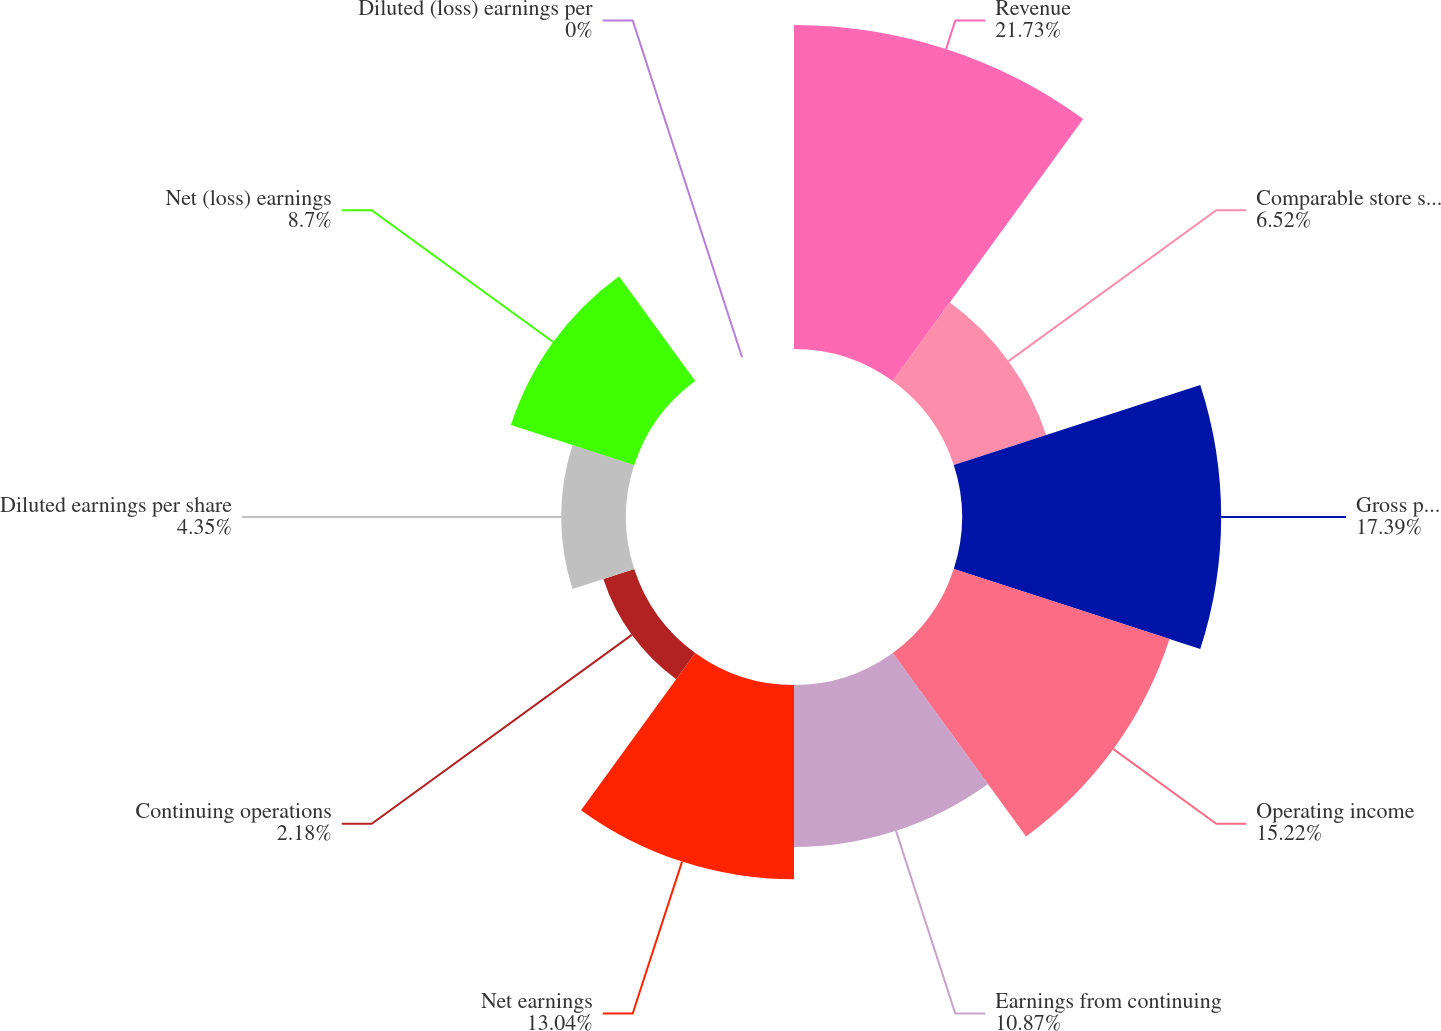Convert chart. <chart><loc_0><loc_0><loc_500><loc_500><pie_chart><fcel>Revenue<fcel>Comparable store sales change<fcel>Gross profit<fcel>Operating income<fcel>Earnings from continuing<fcel>Net earnings<fcel>Continuing operations<fcel>Diluted earnings per share<fcel>Net (loss) earnings<fcel>Diluted (loss) earnings per<nl><fcel>21.74%<fcel>6.52%<fcel>17.39%<fcel>15.22%<fcel>10.87%<fcel>13.04%<fcel>2.18%<fcel>4.35%<fcel>8.7%<fcel>0.0%<nl></chart> 